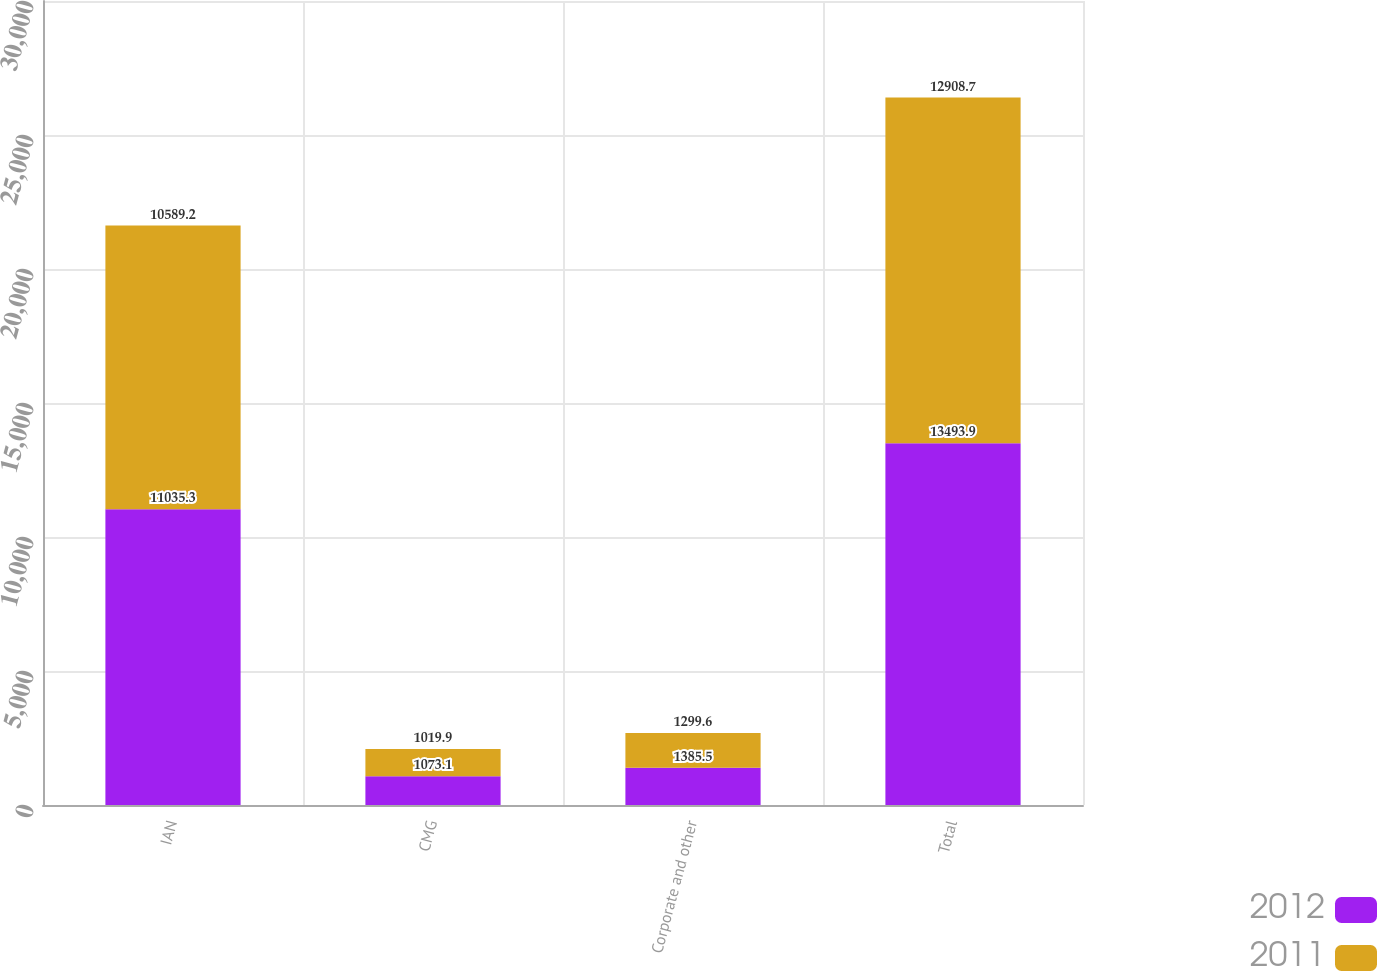Convert chart. <chart><loc_0><loc_0><loc_500><loc_500><stacked_bar_chart><ecel><fcel>IAN<fcel>CMG<fcel>Corporate and other<fcel>Total<nl><fcel>2012<fcel>11035.3<fcel>1073.1<fcel>1385.5<fcel>13493.9<nl><fcel>2011<fcel>10589.2<fcel>1019.9<fcel>1299.6<fcel>12908.7<nl></chart> 